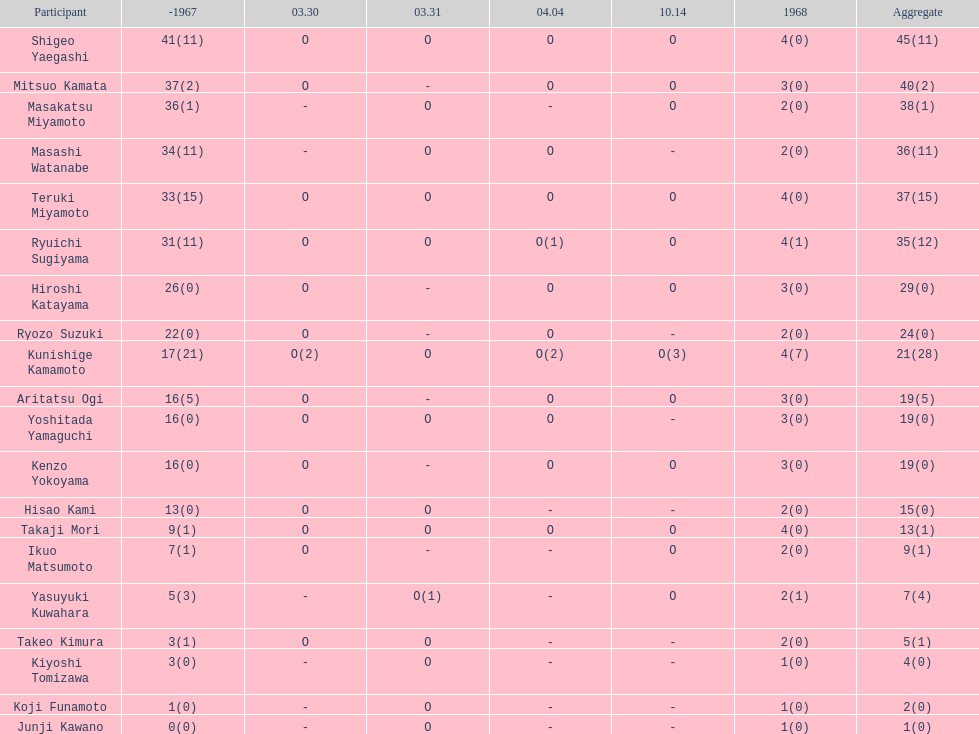How many total did mitsuo kamata have? 40(2). 